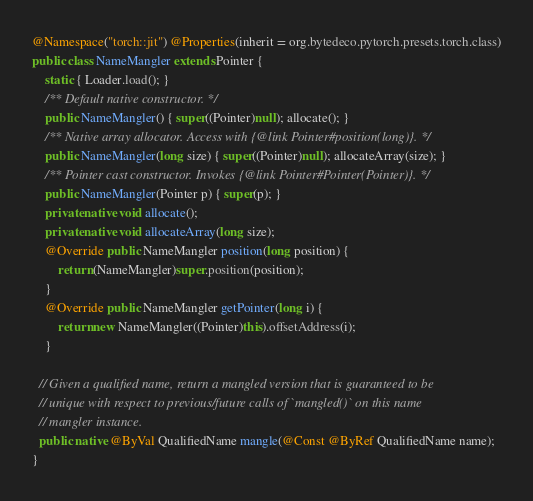<code> <loc_0><loc_0><loc_500><loc_500><_Java_>@Namespace("torch::jit") @Properties(inherit = org.bytedeco.pytorch.presets.torch.class)
public class NameMangler extends Pointer {
    static { Loader.load(); }
    /** Default native constructor. */
    public NameMangler() { super((Pointer)null); allocate(); }
    /** Native array allocator. Access with {@link Pointer#position(long)}. */
    public NameMangler(long size) { super((Pointer)null); allocateArray(size); }
    /** Pointer cast constructor. Invokes {@link Pointer#Pointer(Pointer)}. */
    public NameMangler(Pointer p) { super(p); }
    private native void allocate();
    private native void allocateArray(long size);
    @Override public NameMangler position(long position) {
        return (NameMangler)super.position(position);
    }
    @Override public NameMangler getPointer(long i) {
        return new NameMangler((Pointer)this).offsetAddress(i);
    }

  // Given a qualified name, return a mangled version that is guaranteed to be
  // unique with respect to previous/future calls of `mangled()` on this name
  // mangler instance.
  public native @ByVal QualifiedName mangle(@Const @ByRef QualifiedName name);
}
</code> 